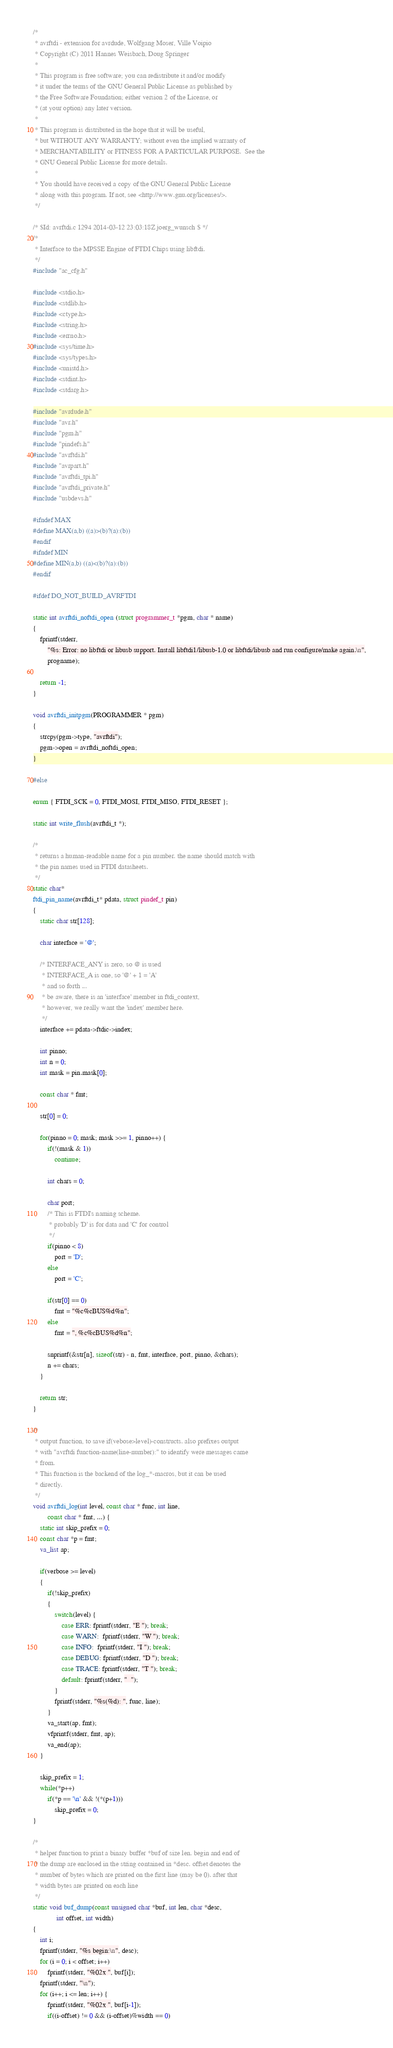<code> <loc_0><loc_0><loc_500><loc_500><_C_>/*
 * avrftdi - extension for avrdude, Wolfgang Moser, Ville Voipio
 * Copyright (C) 2011 Hannes Weisbach, Doug Springer
 *
 * This program is free software; you can redistribute it and/or modify
 * it under the terms of the GNU General Public License as published by
 * the Free Software Foundation; either version 2 of the License, or
 * (at your option) any later version.
 *
 * This program is distributed in the hope that it will be useful,
 * but WITHOUT ANY WARRANTY; without even the implied warranty of
 * MERCHANTABILITY or FITNESS FOR A PARTICULAR PURPOSE.  See the
 * GNU General Public License for more details.
 *
 * You should have received a copy of the GNU General Public License
 * along with this program. If not, see <http://www.gnu.org/licenses/>.
 */

/* $Id: avrftdi.c 1294 2014-03-12 23:03:18Z joerg_wunsch $ */
/*
 * Interface to the MPSSE Engine of FTDI Chips using libftdi.
 */
#include "ac_cfg.h"

#include <stdio.h>
#include <stdlib.h>
#include <ctype.h>
#include <string.h>
#include <errno.h>
#include <sys/time.h>
#include <sys/types.h>
#include <unistd.h>
#include <stdint.h>
#include <stdarg.h>

#include "avrdude.h"
#include "avr.h"
#include "pgm.h"
#include "pindefs.h"
#include "avrftdi.h"
#include "avrpart.h"
#include "avrftdi_tpi.h"
#include "avrftdi_private.h"
#include "usbdevs.h"

#ifndef MAX
#define MAX(a,b) ((a)>(b)?(a):(b))
#endif
#ifndef MIN
#define MIN(a,b) ((a)<(b)?(a):(b))
#endif

#ifdef DO_NOT_BUILD_AVRFTDI

static int avrftdi_noftdi_open (struct programmer_t *pgm, char * name)
{
	fprintf(stderr,
		"%s: Error: no libftdi or libusb support. Install libftdi1/libusb-1.0 or libftdi/libusb and run configure/make again.\n",
		progname);

	return -1;
}

void avrftdi_initpgm(PROGRAMMER * pgm)
{
	strcpy(pgm->type, "avrftdi");
	pgm->open = avrftdi_noftdi_open;
}

#else

enum { FTDI_SCK = 0, FTDI_MOSI, FTDI_MISO, FTDI_RESET };

static int write_flush(avrftdi_t *);

/*
 * returns a human-readable name for a pin number. the name should match with
 * the pin names used in FTDI datasheets.
 */
static char*
ftdi_pin_name(avrftdi_t* pdata, struct pindef_t pin)
{
	static char str[128];

	char interface = '@';

	/* INTERFACE_ANY is zero, so @ is used
	 * INTERFACE_A is one, so '@' + 1 = 'A'
	 * and so forth ...
	 * be aware, there is an 'interface' member in ftdi_context,
	 * however, we really want the 'index' member here.
	 */
	interface += pdata->ftdic->index;

	int pinno;
	int n = 0;
	int mask = pin.mask[0];

	const char * fmt;

	str[0] = 0;

	for(pinno = 0; mask; mask >>= 1, pinno++) {
		if(!(mask & 1))
			continue;

		int chars = 0;

		char port;
		/* This is FTDI's naming scheme.
		 * probably 'D' is for data and 'C' for control
		 */
		if(pinno < 8)
			port = 'D';
		else
			port = 'C';

		if(str[0] == 0)
			fmt = "%c%cBUS%d%n";
		else
			fmt = ", %c%cBUS%d%n";

		snprintf(&str[n], sizeof(str) - n, fmt, interface, port, pinno, &chars);
		n += chars;
	}

	return str;
}

/*
 * output function, to save if(vebose>level)-constructs. also prefixes output
 * with "avrftdi function-name(line-number):" to identify were messages came
 * from.
 * This function is the backend of the log_*-macros, but it can be used
 * directly.
 */
void avrftdi_log(int level, const char * func, int line,
		const char * fmt, ...) {
	static int skip_prefix = 0;
	const char *p = fmt;
	va_list ap;

	if(verbose >= level)
	{
		if(!skip_prefix)
		{
			switch(level) {
				case ERR: fprintf(stderr, "E "); break;
				case WARN:  fprintf(stderr, "W "); break;
				case INFO:  fprintf(stderr, "I "); break;
				case DEBUG: fprintf(stderr, "D "); break;
				case TRACE: fprintf(stderr, "T "); break;
				default: fprintf(stderr, "  ");
			}
			fprintf(stderr, "%s(%d): ", func, line);
		}
		va_start(ap, fmt);
		vfprintf(stderr, fmt, ap);
		va_end(ap);
	}

	skip_prefix = 1;
	while(*p++)
		if(*p == '\n' && !(*(p+1)))
			skip_prefix = 0;
}

/*
 * helper function to print a binary buffer *buf of size len. begin and end of
 * the dump are enclosed in the string contained in *desc. offset denotes the
 * number of bytes which are printed on the first line (may be 0). after that
 * width bytes are printed on each line
 */
static void buf_dump(const unsigned char *buf, int len, char *desc,
		     int offset, int width)
{
	int i;
	fprintf(stderr, "%s begin:\n", desc);
	for (i = 0; i < offset; i++)
		fprintf(stderr, "%02x ", buf[i]);
	fprintf(stderr, "\n");
	for (i++; i <= len; i++) {
		fprintf(stderr, "%02x ", buf[i-1]);
		if((i-offset) != 0 && (i-offset)%width == 0)</code> 